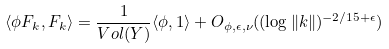Convert formula to latex. <formula><loc_0><loc_0><loc_500><loc_500>\langle \phi F _ { k } , F _ { k } \rangle = \frac { 1 } { V o l ( Y ) } \langle \phi , 1 \rangle + O _ { \phi , \epsilon , \nu } ( ( \log \| k \| ) ^ { - 2 / 1 5 + \epsilon } )</formula> 